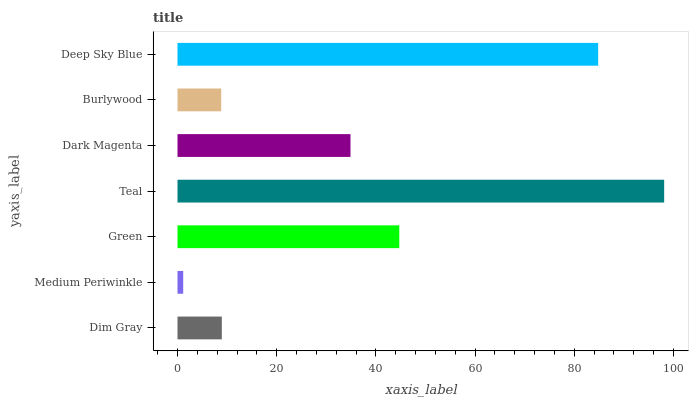Is Medium Periwinkle the minimum?
Answer yes or no. Yes. Is Teal the maximum?
Answer yes or no. Yes. Is Green the minimum?
Answer yes or no. No. Is Green the maximum?
Answer yes or no. No. Is Green greater than Medium Periwinkle?
Answer yes or no. Yes. Is Medium Periwinkle less than Green?
Answer yes or no. Yes. Is Medium Periwinkle greater than Green?
Answer yes or no. No. Is Green less than Medium Periwinkle?
Answer yes or no. No. Is Dark Magenta the high median?
Answer yes or no. Yes. Is Dark Magenta the low median?
Answer yes or no. Yes. Is Medium Periwinkle the high median?
Answer yes or no. No. Is Teal the low median?
Answer yes or no. No. 